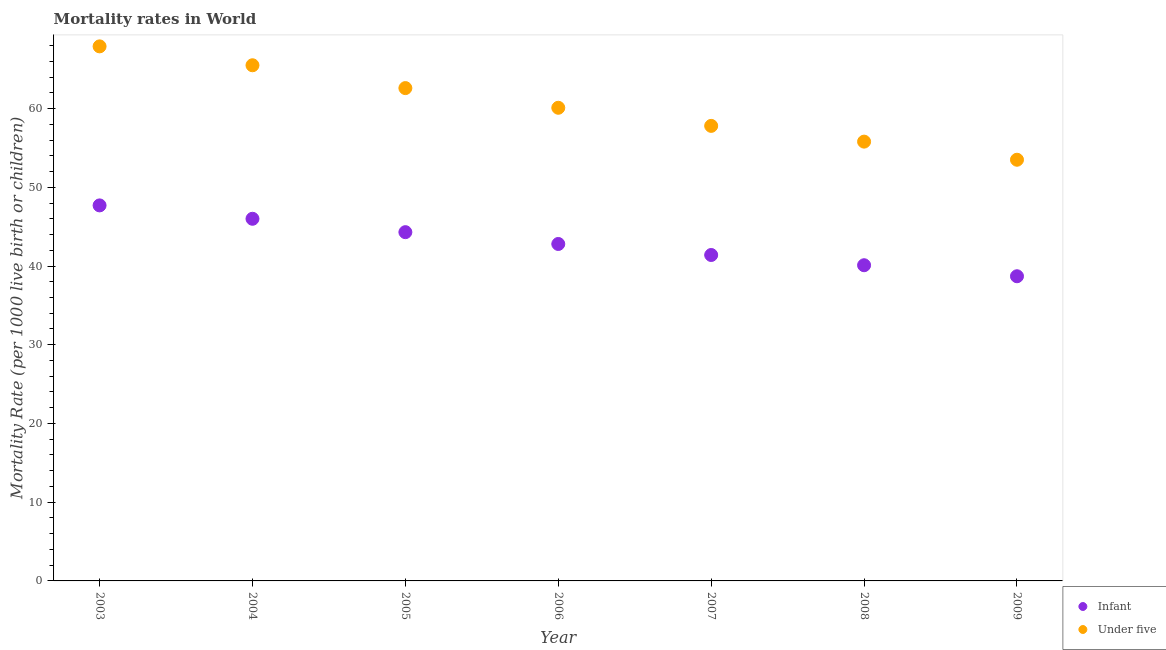How many different coloured dotlines are there?
Provide a succinct answer. 2. What is the infant mortality rate in 2006?
Provide a short and direct response. 42.8. Across all years, what is the maximum under-5 mortality rate?
Give a very brief answer. 67.9. Across all years, what is the minimum infant mortality rate?
Offer a very short reply. 38.7. What is the total under-5 mortality rate in the graph?
Make the answer very short. 423.2. What is the difference between the infant mortality rate in 2004 and that in 2008?
Make the answer very short. 5.9. In the year 2008, what is the difference between the under-5 mortality rate and infant mortality rate?
Ensure brevity in your answer.  15.7. What is the ratio of the under-5 mortality rate in 2006 to that in 2008?
Offer a terse response. 1.08. Is the difference between the under-5 mortality rate in 2007 and 2008 greater than the difference between the infant mortality rate in 2007 and 2008?
Give a very brief answer. Yes. What is the difference between the highest and the second highest under-5 mortality rate?
Keep it short and to the point. 2.4. What is the difference between the highest and the lowest under-5 mortality rate?
Offer a very short reply. 14.4. Is the sum of the infant mortality rate in 2005 and 2006 greater than the maximum under-5 mortality rate across all years?
Your answer should be very brief. Yes. Is the under-5 mortality rate strictly greater than the infant mortality rate over the years?
Ensure brevity in your answer.  Yes. Is the under-5 mortality rate strictly less than the infant mortality rate over the years?
Ensure brevity in your answer.  No. How many dotlines are there?
Provide a succinct answer. 2. How many years are there in the graph?
Your answer should be very brief. 7. What is the difference between two consecutive major ticks on the Y-axis?
Your answer should be very brief. 10. Are the values on the major ticks of Y-axis written in scientific E-notation?
Your answer should be very brief. No. Does the graph contain grids?
Ensure brevity in your answer.  No. How many legend labels are there?
Make the answer very short. 2. What is the title of the graph?
Make the answer very short. Mortality rates in World. Does "Long-term debt" appear as one of the legend labels in the graph?
Offer a very short reply. No. What is the label or title of the Y-axis?
Your answer should be very brief. Mortality Rate (per 1000 live birth or children). What is the Mortality Rate (per 1000 live birth or children) of Infant in 2003?
Ensure brevity in your answer.  47.7. What is the Mortality Rate (per 1000 live birth or children) of Under five in 2003?
Your answer should be very brief. 67.9. What is the Mortality Rate (per 1000 live birth or children) of Infant in 2004?
Your answer should be compact. 46. What is the Mortality Rate (per 1000 live birth or children) of Under five in 2004?
Offer a terse response. 65.5. What is the Mortality Rate (per 1000 live birth or children) of Infant in 2005?
Provide a succinct answer. 44.3. What is the Mortality Rate (per 1000 live birth or children) in Under five in 2005?
Offer a terse response. 62.6. What is the Mortality Rate (per 1000 live birth or children) in Infant in 2006?
Offer a very short reply. 42.8. What is the Mortality Rate (per 1000 live birth or children) of Under five in 2006?
Offer a very short reply. 60.1. What is the Mortality Rate (per 1000 live birth or children) of Infant in 2007?
Your response must be concise. 41.4. What is the Mortality Rate (per 1000 live birth or children) of Under five in 2007?
Give a very brief answer. 57.8. What is the Mortality Rate (per 1000 live birth or children) of Infant in 2008?
Offer a terse response. 40.1. What is the Mortality Rate (per 1000 live birth or children) in Under five in 2008?
Your answer should be compact. 55.8. What is the Mortality Rate (per 1000 live birth or children) in Infant in 2009?
Ensure brevity in your answer.  38.7. What is the Mortality Rate (per 1000 live birth or children) of Under five in 2009?
Make the answer very short. 53.5. Across all years, what is the maximum Mortality Rate (per 1000 live birth or children) of Infant?
Provide a short and direct response. 47.7. Across all years, what is the maximum Mortality Rate (per 1000 live birth or children) of Under five?
Make the answer very short. 67.9. Across all years, what is the minimum Mortality Rate (per 1000 live birth or children) in Infant?
Provide a succinct answer. 38.7. Across all years, what is the minimum Mortality Rate (per 1000 live birth or children) in Under five?
Provide a short and direct response. 53.5. What is the total Mortality Rate (per 1000 live birth or children) in Infant in the graph?
Your response must be concise. 301. What is the total Mortality Rate (per 1000 live birth or children) in Under five in the graph?
Your response must be concise. 423.2. What is the difference between the Mortality Rate (per 1000 live birth or children) of Infant in 2003 and that in 2004?
Provide a succinct answer. 1.7. What is the difference between the Mortality Rate (per 1000 live birth or children) of Infant in 2003 and that in 2005?
Provide a succinct answer. 3.4. What is the difference between the Mortality Rate (per 1000 live birth or children) of Infant in 2003 and that in 2006?
Offer a very short reply. 4.9. What is the difference between the Mortality Rate (per 1000 live birth or children) of Under five in 2003 and that in 2007?
Provide a succinct answer. 10.1. What is the difference between the Mortality Rate (per 1000 live birth or children) of Infant in 2003 and that in 2008?
Provide a succinct answer. 7.6. What is the difference between the Mortality Rate (per 1000 live birth or children) of Under five in 2003 and that in 2008?
Give a very brief answer. 12.1. What is the difference between the Mortality Rate (per 1000 live birth or children) of Under five in 2003 and that in 2009?
Provide a succinct answer. 14.4. What is the difference between the Mortality Rate (per 1000 live birth or children) of Infant in 2004 and that in 2006?
Give a very brief answer. 3.2. What is the difference between the Mortality Rate (per 1000 live birth or children) in Under five in 2004 and that in 2006?
Offer a terse response. 5.4. What is the difference between the Mortality Rate (per 1000 live birth or children) of Infant in 2004 and that in 2007?
Offer a terse response. 4.6. What is the difference between the Mortality Rate (per 1000 live birth or children) in Under five in 2004 and that in 2007?
Provide a short and direct response. 7.7. What is the difference between the Mortality Rate (per 1000 live birth or children) of Infant in 2004 and that in 2008?
Ensure brevity in your answer.  5.9. What is the difference between the Mortality Rate (per 1000 live birth or children) in Infant in 2004 and that in 2009?
Give a very brief answer. 7.3. What is the difference between the Mortality Rate (per 1000 live birth or children) of Under five in 2004 and that in 2009?
Your answer should be compact. 12. What is the difference between the Mortality Rate (per 1000 live birth or children) in Under five in 2005 and that in 2008?
Your answer should be very brief. 6.8. What is the difference between the Mortality Rate (per 1000 live birth or children) of Under five in 2006 and that in 2008?
Provide a short and direct response. 4.3. What is the difference between the Mortality Rate (per 1000 live birth or children) in Infant in 2006 and that in 2009?
Your response must be concise. 4.1. What is the difference between the Mortality Rate (per 1000 live birth or children) in Infant in 2007 and that in 2008?
Provide a short and direct response. 1.3. What is the difference between the Mortality Rate (per 1000 live birth or children) in Under five in 2007 and that in 2008?
Offer a very short reply. 2. What is the difference between the Mortality Rate (per 1000 live birth or children) of Under five in 2007 and that in 2009?
Your answer should be compact. 4.3. What is the difference between the Mortality Rate (per 1000 live birth or children) in Infant in 2003 and the Mortality Rate (per 1000 live birth or children) in Under five in 2004?
Offer a terse response. -17.8. What is the difference between the Mortality Rate (per 1000 live birth or children) of Infant in 2003 and the Mortality Rate (per 1000 live birth or children) of Under five in 2005?
Keep it short and to the point. -14.9. What is the difference between the Mortality Rate (per 1000 live birth or children) in Infant in 2003 and the Mortality Rate (per 1000 live birth or children) in Under five in 2006?
Ensure brevity in your answer.  -12.4. What is the difference between the Mortality Rate (per 1000 live birth or children) of Infant in 2003 and the Mortality Rate (per 1000 live birth or children) of Under five in 2008?
Offer a very short reply. -8.1. What is the difference between the Mortality Rate (per 1000 live birth or children) of Infant in 2003 and the Mortality Rate (per 1000 live birth or children) of Under five in 2009?
Your response must be concise. -5.8. What is the difference between the Mortality Rate (per 1000 live birth or children) in Infant in 2004 and the Mortality Rate (per 1000 live birth or children) in Under five in 2005?
Your answer should be very brief. -16.6. What is the difference between the Mortality Rate (per 1000 live birth or children) of Infant in 2004 and the Mortality Rate (per 1000 live birth or children) of Under five in 2006?
Your response must be concise. -14.1. What is the difference between the Mortality Rate (per 1000 live birth or children) in Infant in 2005 and the Mortality Rate (per 1000 live birth or children) in Under five in 2006?
Make the answer very short. -15.8. What is the difference between the Mortality Rate (per 1000 live birth or children) in Infant in 2005 and the Mortality Rate (per 1000 live birth or children) in Under five in 2008?
Keep it short and to the point. -11.5. What is the difference between the Mortality Rate (per 1000 live birth or children) of Infant in 2006 and the Mortality Rate (per 1000 live birth or children) of Under five in 2007?
Make the answer very short. -15. What is the difference between the Mortality Rate (per 1000 live birth or children) of Infant in 2006 and the Mortality Rate (per 1000 live birth or children) of Under five in 2008?
Keep it short and to the point. -13. What is the difference between the Mortality Rate (per 1000 live birth or children) of Infant in 2007 and the Mortality Rate (per 1000 live birth or children) of Under five in 2008?
Ensure brevity in your answer.  -14.4. What is the difference between the Mortality Rate (per 1000 live birth or children) in Infant in 2008 and the Mortality Rate (per 1000 live birth or children) in Under five in 2009?
Keep it short and to the point. -13.4. What is the average Mortality Rate (per 1000 live birth or children) of Infant per year?
Provide a short and direct response. 43. What is the average Mortality Rate (per 1000 live birth or children) of Under five per year?
Ensure brevity in your answer.  60.46. In the year 2003, what is the difference between the Mortality Rate (per 1000 live birth or children) in Infant and Mortality Rate (per 1000 live birth or children) in Under five?
Make the answer very short. -20.2. In the year 2004, what is the difference between the Mortality Rate (per 1000 live birth or children) in Infant and Mortality Rate (per 1000 live birth or children) in Under five?
Give a very brief answer. -19.5. In the year 2005, what is the difference between the Mortality Rate (per 1000 live birth or children) in Infant and Mortality Rate (per 1000 live birth or children) in Under five?
Offer a terse response. -18.3. In the year 2006, what is the difference between the Mortality Rate (per 1000 live birth or children) of Infant and Mortality Rate (per 1000 live birth or children) of Under five?
Your answer should be compact. -17.3. In the year 2007, what is the difference between the Mortality Rate (per 1000 live birth or children) in Infant and Mortality Rate (per 1000 live birth or children) in Under five?
Offer a very short reply. -16.4. In the year 2008, what is the difference between the Mortality Rate (per 1000 live birth or children) of Infant and Mortality Rate (per 1000 live birth or children) of Under five?
Offer a terse response. -15.7. In the year 2009, what is the difference between the Mortality Rate (per 1000 live birth or children) of Infant and Mortality Rate (per 1000 live birth or children) of Under five?
Your response must be concise. -14.8. What is the ratio of the Mortality Rate (per 1000 live birth or children) in Infant in 2003 to that in 2004?
Your answer should be very brief. 1.04. What is the ratio of the Mortality Rate (per 1000 live birth or children) in Under five in 2003 to that in 2004?
Give a very brief answer. 1.04. What is the ratio of the Mortality Rate (per 1000 live birth or children) in Infant in 2003 to that in 2005?
Your response must be concise. 1.08. What is the ratio of the Mortality Rate (per 1000 live birth or children) in Under five in 2003 to that in 2005?
Provide a succinct answer. 1.08. What is the ratio of the Mortality Rate (per 1000 live birth or children) of Infant in 2003 to that in 2006?
Your response must be concise. 1.11. What is the ratio of the Mortality Rate (per 1000 live birth or children) of Under five in 2003 to that in 2006?
Offer a very short reply. 1.13. What is the ratio of the Mortality Rate (per 1000 live birth or children) of Infant in 2003 to that in 2007?
Offer a terse response. 1.15. What is the ratio of the Mortality Rate (per 1000 live birth or children) of Under five in 2003 to that in 2007?
Offer a very short reply. 1.17. What is the ratio of the Mortality Rate (per 1000 live birth or children) of Infant in 2003 to that in 2008?
Ensure brevity in your answer.  1.19. What is the ratio of the Mortality Rate (per 1000 live birth or children) in Under five in 2003 to that in 2008?
Offer a terse response. 1.22. What is the ratio of the Mortality Rate (per 1000 live birth or children) of Infant in 2003 to that in 2009?
Provide a succinct answer. 1.23. What is the ratio of the Mortality Rate (per 1000 live birth or children) in Under five in 2003 to that in 2009?
Provide a short and direct response. 1.27. What is the ratio of the Mortality Rate (per 1000 live birth or children) in Infant in 2004 to that in 2005?
Your answer should be compact. 1.04. What is the ratio of the Mortality Rate (per 1000 live birth or children) of Under five in 2004 to that in 2005?
Make the answer very short. 1.05. What is the ratio of the Mortality Rate (per 1000 live birth or children) of Infant in 2004 to that in 2006?
Make the answer very short. 1.07. What is the ratio of the Mortality Rate (per 1000 live birth or children) of Under five in 2004 to that in 2006?
Keep it short and to the point. 1.09. What is the ratio of the Mortality Rate (per 1000 live birth or children) in Infant in 2004 to that in 2007?
Give a very brief answer. 1.11. What is the ratio of the Mortality Rate (per 1000 live birth or children) of Under five in 2004 to that in 2007?
Keep it short and to the point. 1.13. What is the ratio of the Mortality Rate (per 1000 live birth or children) of Infant in 2004 to that in 2008?
Keep it short and to the point. 1.15. What is the ratio of the Mortality Rate (per 1000 live birth or children) in Under five in 2004 to that in 2008?
Your answer should be very brief. 1.17. What is the ratio of the Mortality Rate (per 1000 live birth or children) of Infant in 2004 to that in 2009?
Your answer should be very brief. 1.19. What is the ratio of the Mortality Rate (per 1000 live birth or children) of Under five in 2004 to that in 2009?
Offer a terse response. 1.22. What is the ratio of the Mortality Rate (per 1000 live birth or children) of Infant in 2005 to that in 2006?
Ensure brevity in your answer.  1.03. What is the ratio of the Mortality Rate (per 1000 live birth or children) in Under five in 2005 to that in 2006?
Your response must be concise. 1.04. What is the ratio of the Mortality Rate (per 1000 live birth or children) of Infant in 2005 to that in 2007?
Provide a succinct answer. 1.07. What is the ratio of the Mortality Rate (per 1000 live birth or children) of Under five in 2005 to that in 2007?
Give a very brief answer. 1.08. What is the ratio of the Mortality Rate (per 1000 live birth or children) in Infant in 2005 to that in 2008?
Ensure brevity in your answer.  1.1. What is the ratio of the Mortality Rate (per 1000 live birth or children) in Under five in 2005 to that in 2008?
Offer a terse response. 1.12. What is the ratio of the Mortality Rate (per 1000 live birth or children) of Infant in 2005 to that in 2009?
Your answer should be very brief. 1.14. What is the ratio of the Mortality Rate (per 1000 live birth or children) of Under five in 2005 to that in 2009?
Offer a very short reply. 1.17. What is the ratio of the Mortality Rate (per 1000 live birth or children) in Infant in 2006 to that in 2007?
Keep it short and to the point. 1.03. What is the ratio of the Mortality Rate (per 1000 live birth or children) in Under five in 2006 to that in 2007?
Your answer should be very brief. 1.04. What is the ratio of the Mortality Rate (per 1000 live birth or children) of Infant in 2006 to that in 2008?
Provide a short and direct response. 1.07. What is the ratio of the Mortality Rate (per 1000 live birth or children) in Under five in 2006 to that in 2008?
Ensure brevity in your answer.  1.08. What is the ratio of the Mortality Rate (per 1000 live birth or children) in Infant in 2006 to that in 2009?
Make the answer very short. 1.11. What is the ratio of the Mortality Rate (per 1000 live birth or children) in Under five in 2006 to that in 2009?
Offer a terse response. 1.12. What is the ratio of the Mortality Rate (per 1000 live birth or children) of Infant in 2007 to that in 2008?
Your response must be concise. 1.03. What is the ratio of the Mortality Rate (per 1000 live birth or children) in Under five in 2007 to that in 2008?
Provide a succinct answer. 1.04. What is the ratio of the Mortality Rate (per 1000 live birth or children) of Infant in 2007 to that in 2009?
Your response must be concise. 1.07. What is the ratio of the Mortality Rate (per 1000 live birth or children) in Under five in 2007 to that in 2009?
Offer a terse response. 1.08. What is the ratio of the Mortality Rate (per 1000 live birth or children) in Infant in 2008 to that in 2009?
Provide a short and direct response. 1.04. What is the ratio of the Mortality Rate (per 1000 live birth or children) of Under five in 2008 to that in 2009?
Make the answer very short. 1.04. What is the difference between the highest and the second highest Mortality Rate (per 1000 live birth or children) of Infant?
Your response must be concise. 1.7. What is the difference between the highest and the second highest Mortality Rate (per 1000 live birth or children) in Under five?
Offer a very short reply. 2.4. What is the difference between the highest and the lowest Mortality Rate (per 1000 live birth or children) in Under five?
Your answer should be compact. 14.4. 